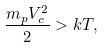<formula> <loc_0><loc_0><loc_500><loc_500>\frac { m _ { p } V _ { c } ^ { 2 } } { 2 } > k T ,</formula> 